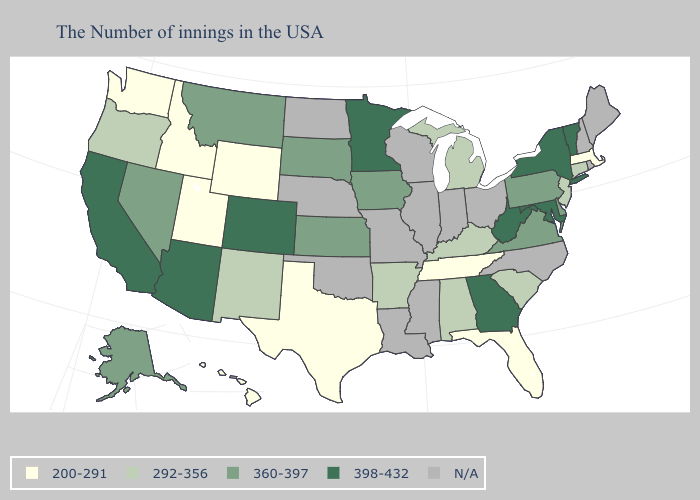What is the value of South Carolina?
Short answer required. 292-356. What is the lowest value in the South?
Quick response, please. 200-291. What is the highest value in the West ?
Be succinct. 398-432. What is the value of California?
Give a very brief answer. 398-432. Name the states that have a value in the range 360-397?
Be succinct. Delaware, Pennsylvania, Virginia, Iowa, Kansas, South Dakota, Montana, Nevada, Alaska. Among the states that border Massachusetts , does Connecticut have the highest value?
Be succinct. No. Does the first symbol in the legend represent the smallest category?
Write a very short answer. Yes. Does Hawaii have the highest value in the West?
Write a very short answer. No. What is the lowest value in states that border Alabama?
Give a very brief answer. 200-291. Name the states that have a value in the range 200-291?
Be succinct. Massachusetts, Florida, Tennessee, Texas, Wyoming, Utah, Idaho, Washington, Hawaii. What is the value of Utah?
Answer briefly. 200-291. What is the value of Delaware?
Write a very short answer. 360-397. Name the states that have a value in the range 360-397?
Give a very brief answer. Delaware, Pennsylvania, Virginia, Iowa, Kansas, South Dakota, Montana, Nevada, Alaska. What is the highest value in states that border Florida?
Short answer required. 398-432. 